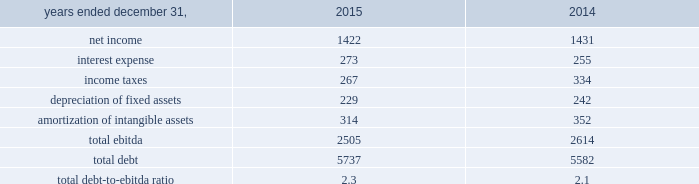On may 20 , 2015 , aon plc issued $ 600 million of 4.750% ( 4.750 % ) senior notes due may 2045 .
The 4.750% ( 4.750 % ) notes due may 2045 are fully and unconditionally guaranteed by aon corporation .
We used the proceeds of the issuance for general corporate purposes .
On september 30 , 2015 , $ 600 million of 3.50% ( 3.50 % ) senior notes issued by aon corporation matured and were repaid .
On november 13 , 2015 , aon plc issued $ 400 million of 2.80% ( 2.80 % ) senior notes due march 2021 .
The 2.80% ( 2.80 % ) notes due march 2021 are fully and unconditionally guaranteed by aon corporation .
We used the proceeds of the issuance for general corporate purposes .
Credit facilities as of december 31 , 2015 , we had two committed credit facilities outstanding : our $ 400 million u.s .
Credit facility expiring in march 2017 ( the "2017 facility" ) and $ 900 million multi-currency u.s .
Credit facility expiring in february 2020 ( the "2020 facility" ) .
The 2020 facility was entered into on february 2 , 2015 and replaced the previous 20ac650 million european credit facility .
Each of these facilities is intended to support our commercial paper obligations and our general working capital needs .
In addition , each of these facilities includes customary representations , warranties and covenants , including financial covenants that require us to maintain specified ratios of adjusted consolidated ebitda to consolidated interest expense and consolidated debt to adjusted consolidated ebitda , tested quarterly .
At december 31 , 2015 , we did not have borrowings under either the 2017 facility or the 2020 facility , and we were in compliance with the financial covenants and all other covenants contained therein during the twelve months ended december 31 , 2015 .
Effective february 2 , 2016 , the 2020 facility terms were extended for 1 year and will expire in february 2021 our total debt-to-ebitda ratio at december 31 , 2015 and 2014 , is calculated as follows: .
We use ebitda , as defined by our financial covenants , as a non-gaap measure .
This supplemental information related to ebitda represents a measure not in accordance with u.s .
Gaap and should be viewed in addition to , not instead of , our consolidated financial statements and notes thereto .
Shelf registration statement on september 3 , 2015 , we filed a shelf registration statement with the sec , registering the offer and sale from time to time of an indeterminate amount of , among other securities , debt securities , preference shares , class a ordinary shares and convertible securities .
Our ability to access the market as a source of liquidity is dependent on investor demand , market conditions and other factors. .
What was the percent of the change in the interest expense from 2014 to 2015? 
Computations: ((273 - 255) / 255)
Answer: 0.07059. 